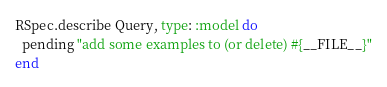Convert code to text. <code><loc_0><loc_0><loc_500><loc_500><_Ruby_>RSpec.describe Query, type: :model do
  pending "add some examples to (or delete) #{__FILE__}"
end
</code> 